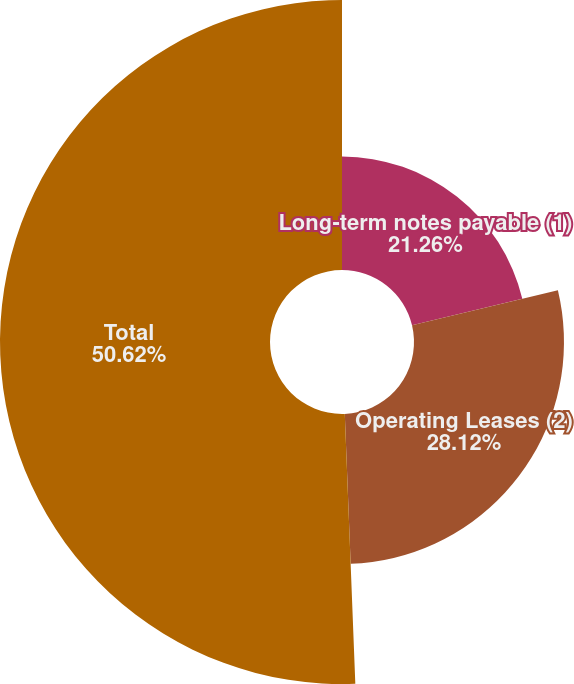Convert chart. <chart><loc_0><loc_0><loc_500><loc_500><pie_chart><fcel>Long-term notes payable (1)<fcel>Operating Leases (2)<fcel>Total<nl><fcel>21.26%<fcel>28.12%<fcel>50.62%<nl></chart> 